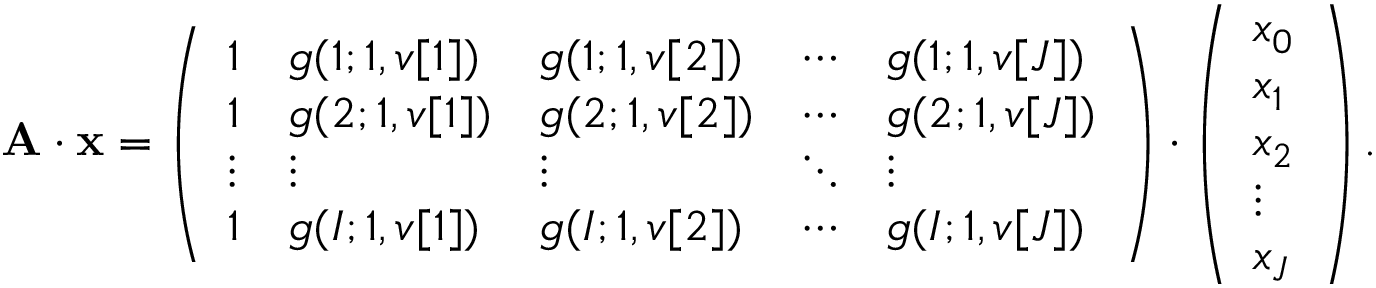<formula> <loc_0><loc_0><loc_500><loc_500>A \cdot x = \left ( \begin{array} { l l l l l } { 1 } & { g ( 1 ; 1 , v [ 1 ] ) } & { g ( 1 ; 1 , v [ 2 ] ) } & { \cdots } & { g ( 1 ; 1 , v [ J ] ) } \\ { 1 } & { g ( 2 ; 1 , v [ 1 ] ) } & { g ( 2 ; 1 , v [ 2 ] ) } & { \cdots } & { g ( 2 ; 1 , v [ J ] ) } \\ { \vdots } & { \vdots } & { \vdots } & { \ddots } & { \vdots } \\ { 1 } & { g ( I ; 1 , v [ 1 ] ) } & { g ( I ; 1 , v [ 2 ] ) } & { \cdots } & { g ( I ; 1 , v [ J ] ) } \end{array} \right ) \cdot \left ( \begin{array} { l } { x _ { 0 } } \\ { x _ { 1 } } \\ { x _ { 2 } } \\ { \vdots } \\ { x _ { J } } \end{array} \right ) .</formula> 